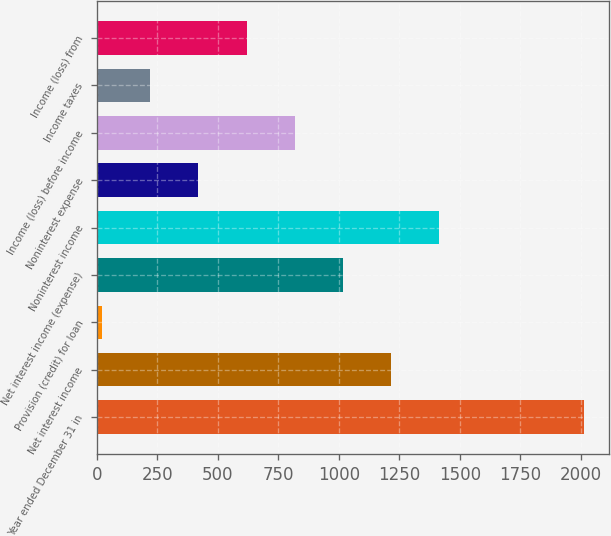Convert chart to OTSL. <chart><loc_0><loc_0><loc_500><loc_500><bar_chart><fcel>Year ended December 31 in<fcel>Net interest income<fcel>Provision (credit) for loan<fcel>Net interest income (expense)<fcel>Noninterest income<fcel>Noninterest expense<fcel>Income (loss) before income<fcel>Income taxes<fcel>Income (loss) from<nl><fcel>2014<fcel>1216.8<fcel>21<fcel>1017.5<fcel>1416.1<fcel>419.6<fcel>818.2<fcel>220.3<fcel>618.9<nl></chart> 